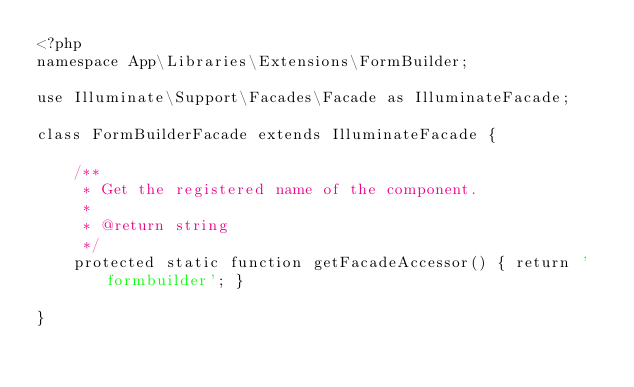<code> <loc_0><loc_0><loc_500><loc_500><_PHP_><?php 
namespace App\Libraries\Extensions\FormBuilder;

use Illuminate\Support\Facades\Facade as IlluminateFacade;

class FormBuilderFacade extends IlluminateFacade {

    /**
     * Get the registered name of the component.
     *
     * @return string
     */
    protected static function getFacadeAccessor() { return 'formbuilder'; }

}</code> 